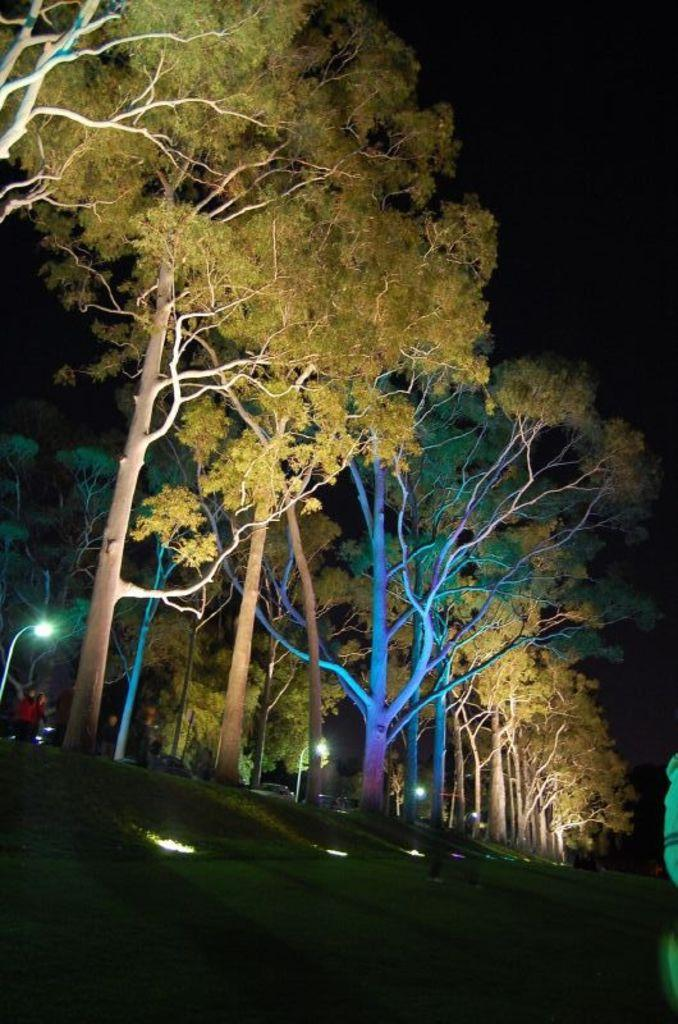What is located at the bottom of the image? There are lights at the bottom of the image. What can be seen in the center of the image? There are trees in the center of the image. Where is the person located in the image? The person is on the left side of the image. How many cats are sitting on the tent in the image? There is no tent or cats present in the image. What type of bird is perched on the wren in the image? There is no wren or bird present in the image. 